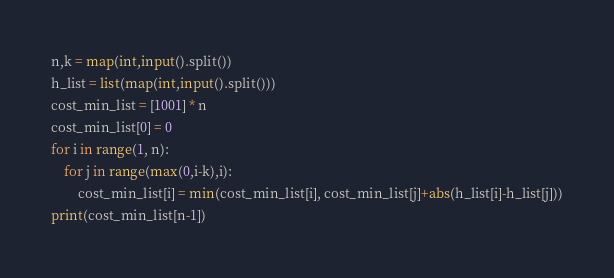Convert code to text. <code><loc_0><loc_0><loc_500><loc_500><_Python_>n,k = map(int,input().split())
h_list = list(map(int,input().split()))
cost_min_list = [1001] * n
cost_min_list[0] = 0
for i in range(1, n):
    for j in range(max(0,i-k),i):
        cost_min_list[i] = min(cost_min_list[i], cost_min_list[j]+abs(h_list[i]-h_list[j]))
print(cost_min_list[n-1])</code> 